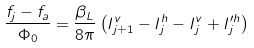Convert formula to latex. <formula><loc_0><loc_0><loc_500><loc_500>\frac { f _ { j } - f _ { a } } { \Phi _ { 0 } } = \frac { \beta _ { L } } { 8 \pi } \left ( I _ { j + 1 } ^ { v } - I _ { j } ^ { h } - I _ { j } ^ { v } + I _ { j } ^ { \prime h } \right )</formula> 